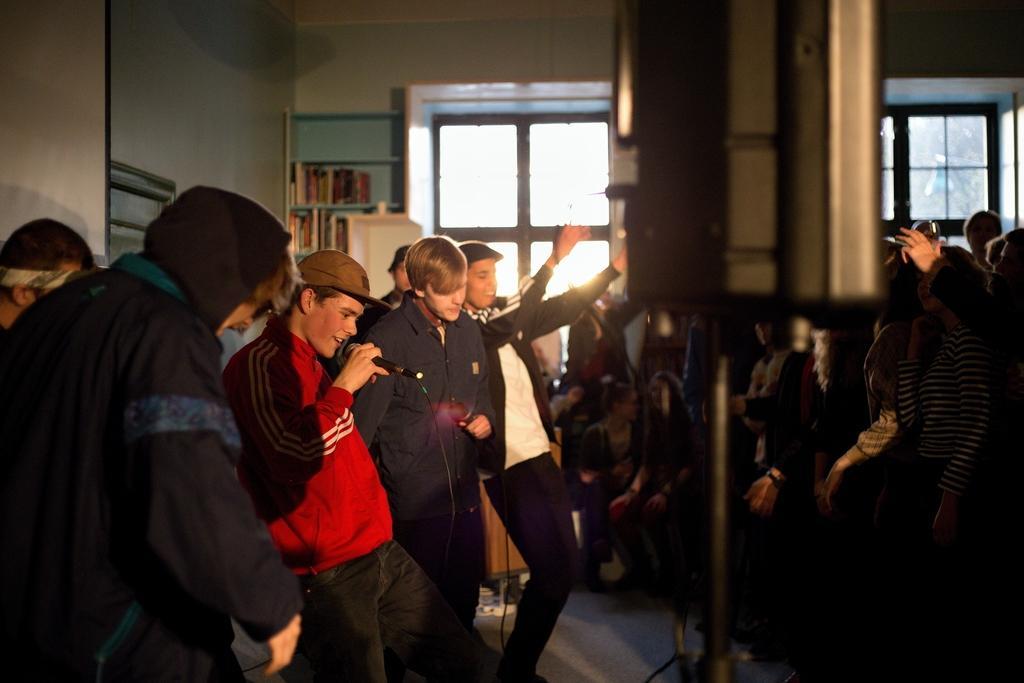Describe this image in one or two sentences. In this image we can see people. The man standing in the center is holding a mic. In the background there is a wall and we can see a shelf. There are books placed in the shelf. There are windows. 